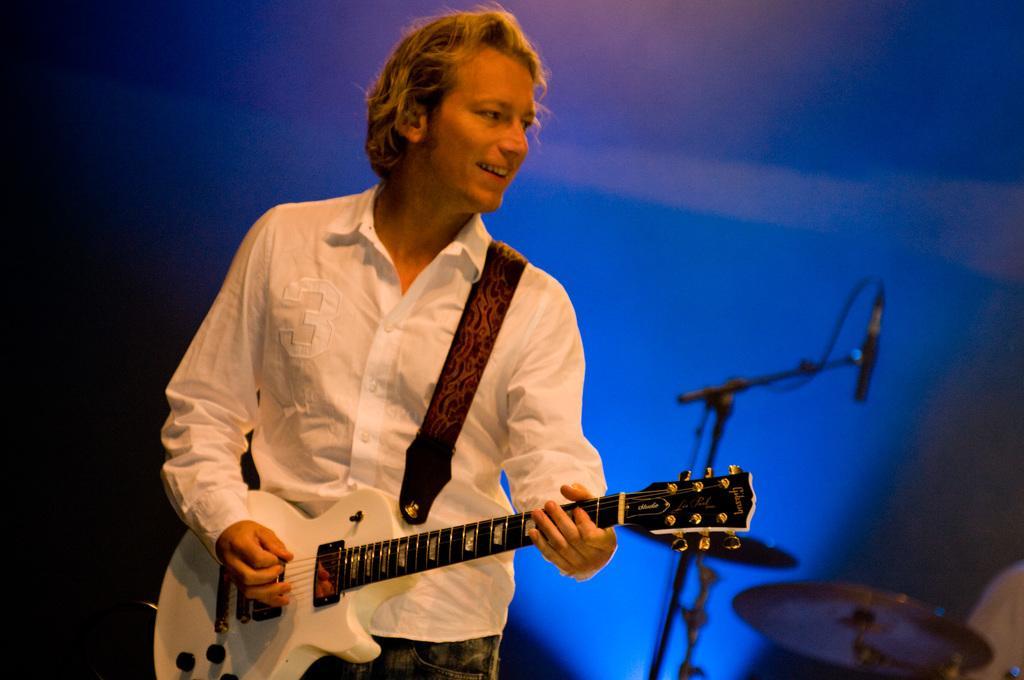Please provide a concise description of this image. In the picture there is a man playing a guitar, he is smiling and behind the man there are some other instruments and the background of the man is blur. 